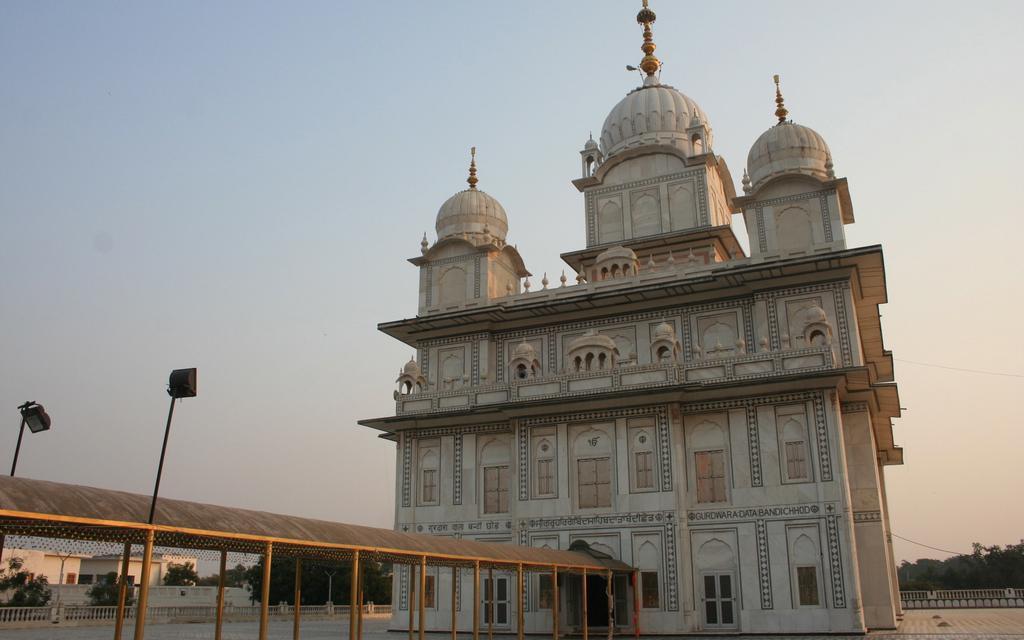How would you summarize this image in a sentence or two? In this image there is a building, in front of the building there is a path, for that path there is a roof, in the background there are trees and the sky. 